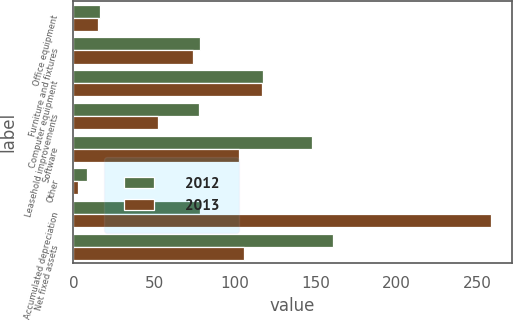Convert chart to OTSL. <chart><loc_0><loc_0><loc_500><loc_500><stacked_bar_chart><ecel><fcel>Office equipment<fcel>Furniture and fixtures<fcel>Computer equipment<fcel>Leasehold improvements<fcel>Software<fcel>Other<fcel>Accumulated depreciation<fcel>Net fixed assets<nl><fcel>2012<fcel>16.3<fcel>78.3<fcel>117.2<fcel>77.9<fcel>147.6<fcel>8.5<fcel>78.3<fcel>160.4<nl><fcel>2013<fcel>15.1<fcel>74.2<fcel>116.7<fcel>52.2<fcel>102.7<fcel>2.9<fcel>258.4<fcel>105.4<nl></chart> 